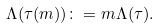Convert formula to latex. <formula><loc_0><loc_0><loc_500><loc_500>\Lambda ( \tau ( m ) ) \colon = m \Lambda ( \tau ) .</formula> 